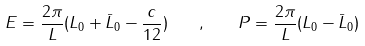<formula> <loc_0><loc_0><loc_500><loc_500>E = \frac { 2 \pi } { L } ( L _ { 0 } + \bar { L } _ { 0 } - \frac { c } { 1 2 } ) \quad , \quad P = \frac { 2 \pi } { L } ( L _ { 0 } - \bar { L } _ { 0 } )</formula> 